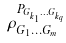Convert formula to latex. <formula><loc_0><loc_0><loc_500><loc_500>\rho _ { G _ { 1 } \dots G _ { m } } ^ { P _ { G _ { k _ { 1 } } \dots G _ { k _ { q } } } }</formula> 